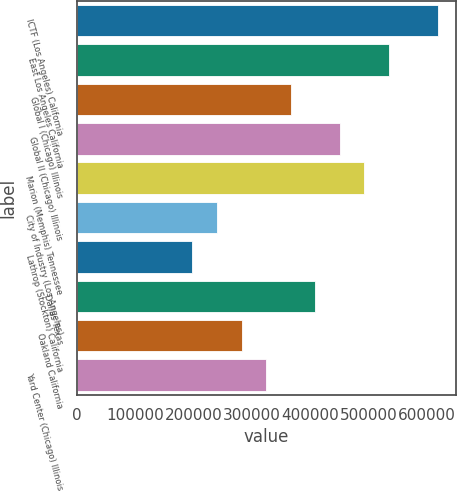Convert chart to OTSL. <chart><loc_0><loc_0><loc_500><loc_500><bar_chart><fcel>ICTF (Los Angeles) California<fcel>East Los Angeles California<fcel>Global I (Chicago) Illinois<fcel>Global II (Chicago) Illinois<fcel>Marion (Memphis) Tennessee<fcel>City of Industry (Los Angeles)<fcel>Lathrop (Stockton) California<fcel>Dallas Texas<fcel>Oakland California<fcel>Yard Center (Chicago) Illinois<nl><fcel>619000<fcel>534800<fcel>366400<fcel>450600<fcel>492700<fcel>240100<fcel>198000<fcel>408500<fcel>282200<fcel>324300<nl></chart> 